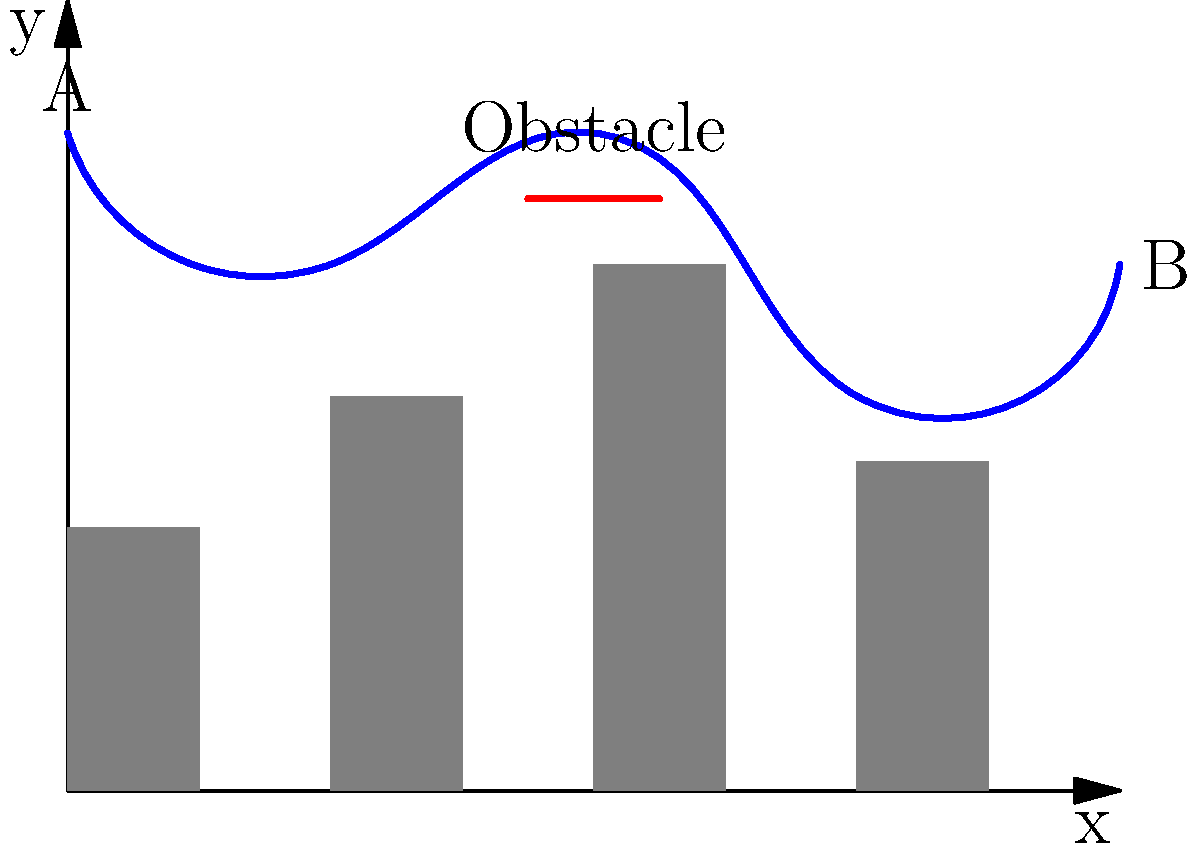A superhero is flying from point A to point B through a cityscape. An unexpected obstacle appears in their path, as shown in the diagram. Considering the ethical implications of property damage and public safety, what adjustment to the flight path would minimize potential harm while still allowing the superhero to reach their destination efficiently? To answer this question, we need to consider several factors:

1. Current trajectory: The superhero's flight path is represented by the blue curve, starting at point A and ending at point B.

2. Obstacle location: There's a red line representing an obstacle at approximately $(4, 4.5)$ on the graph.

3. Building heights: The gray rectangles represent buildings of varying heights.

4. Ethical considerations:
   a) Property damage: Avoid colliding with buildings or the obstacle.
   b) Public safety: Maintain a safe distance from structures and populated areas.
   c) Efficiency: Reach point B in a timely manner.

5. Possible adjustments:
   a) Increase altitude: Flying higher would avoid the obstacle but might compromise efficiency.
   b) Sharp turn: A sudden change in direction could avoid the obstacle but might be risky in terms of control and potential collateral damage.
   c) Gradual curve: A smoother adjustment starting earlier in the flight path could balance safety and efficiency.

6. Optimal solution: A gradual curve that begins adjusting the flight path before reaching the obstacle would be the best option. This allows the superhero to:
   - Maintain a safe distance from buildings
   - Avoid the obstacle without abrupt movements
   - Minimize the risk of property damage or harm to civilians
   - Reach point B efficiently

The adjusted path would ideally start curving upward around $(2, 4)$ on the graph, peak slightly above the obstacle, and then descend smoothly towards point B.
Answer: Gradual upward curve starting at $(2, 4)$, peaking above the obstacle, then descending to B. 